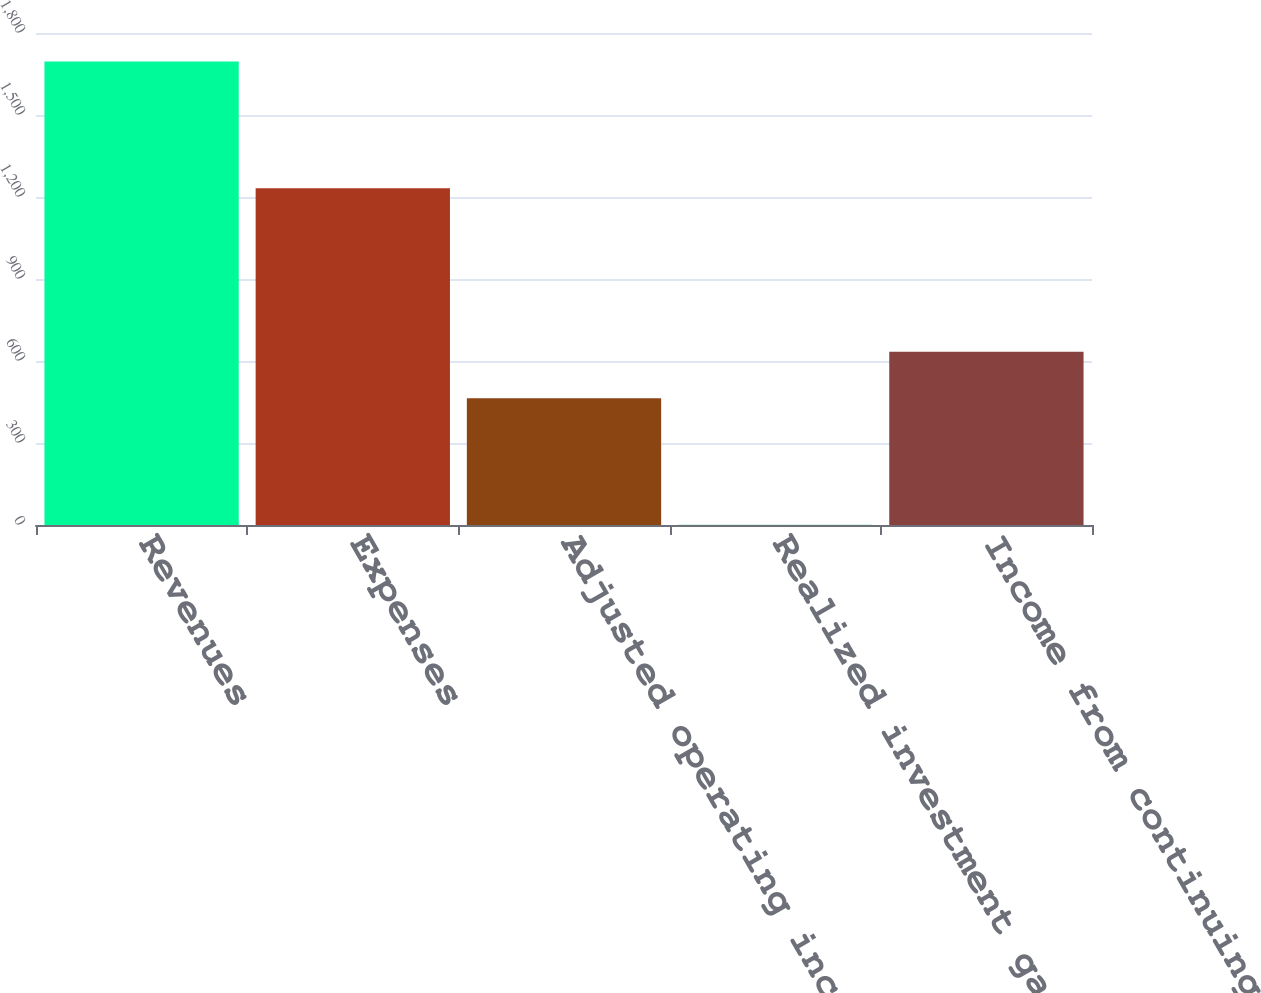<chart> <loc_0><loc_0><loc_500><loc_500><bar_chart><fcel>Revenues<fcel>Expenses<fcel>Adjusted operating income<fcel>Realized investment gains net<fcel>Income from continuing<nl><fcel>1696<fcel>1232<fcel>464<fcel>1<fcel>633.5<nl></chart> 